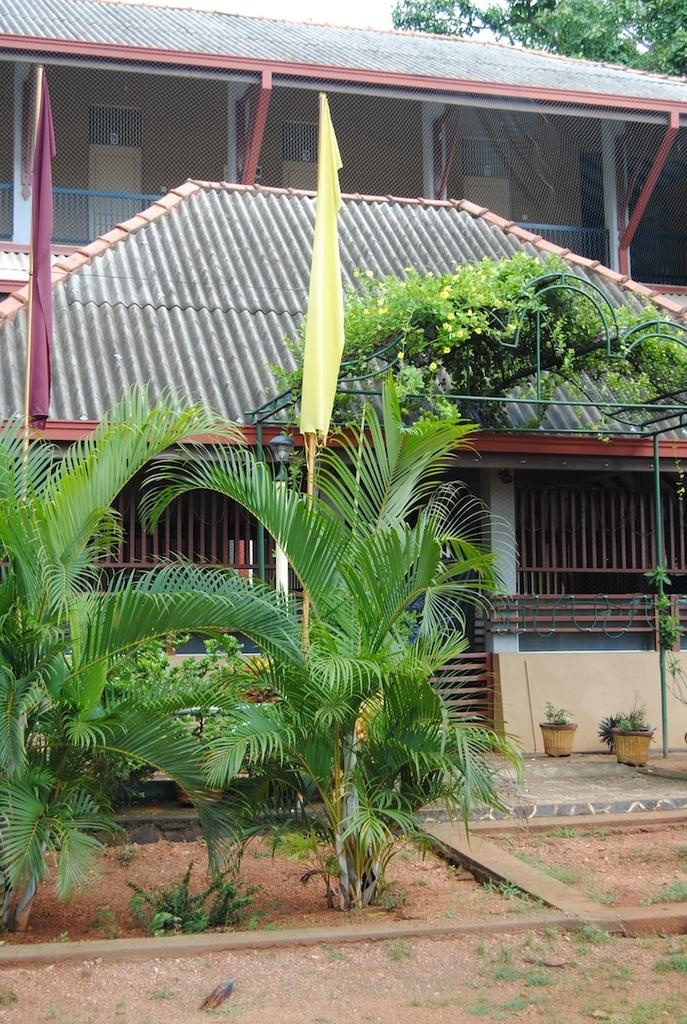What type of structure is visible in the image? There is a house in the image. What can be seen on the ground near the house? There are plants on the ground. How many flags are present in the image, and what are their colors? There are two flags in the image, one purple and one yellow. What is visible in the background of the image? There is a tree in the background of the image. What type of jelly is being served at the house in the image? There is no jelly present in the image, and therefore no such activity can be observed. 